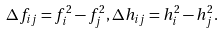Convert formula to latex. <formula><loc_0><loc_0><loc_500><loc_500>\Delta f _ { i j } = f ^ { 2 } _ { i } - f ^ { 2 } _ { j } , \Delta h _ { i j } = h ^ { 2 } _ { i } - h ^ { 2 } _ { j } .</formula> 